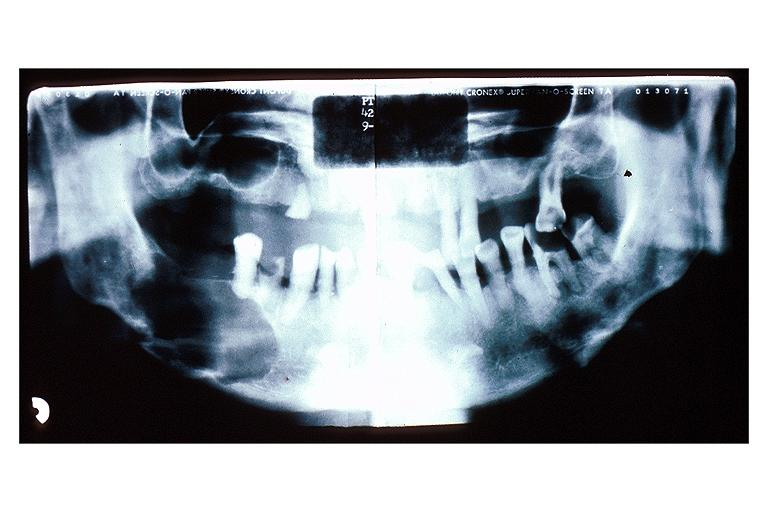where is this?
Answer the question using a single word or phrase. Oral 